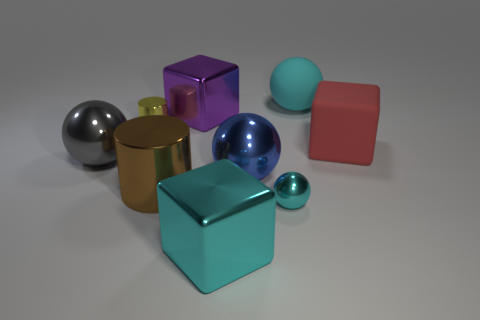Subtract all blue balls. How many balls are left? 3 Subtract all shiny blocks. How many blocks are left? 1 Add 1 small blue rubber cubes. How many objects exist? 10 Subtract all brown balls. Subtract all purple cylinders. How many balls are left? 4 Subtract all cylinders. How many objects are left? 7 Add 8 green balls. How many green balls exist? 8 Subtract 1 blue balls. How many objects are left? 8 Subtract all large gray balls. Subtract all big gray metal objects. How many objects are left? 7 Add 5 matte things. How many matte things are left? 7 